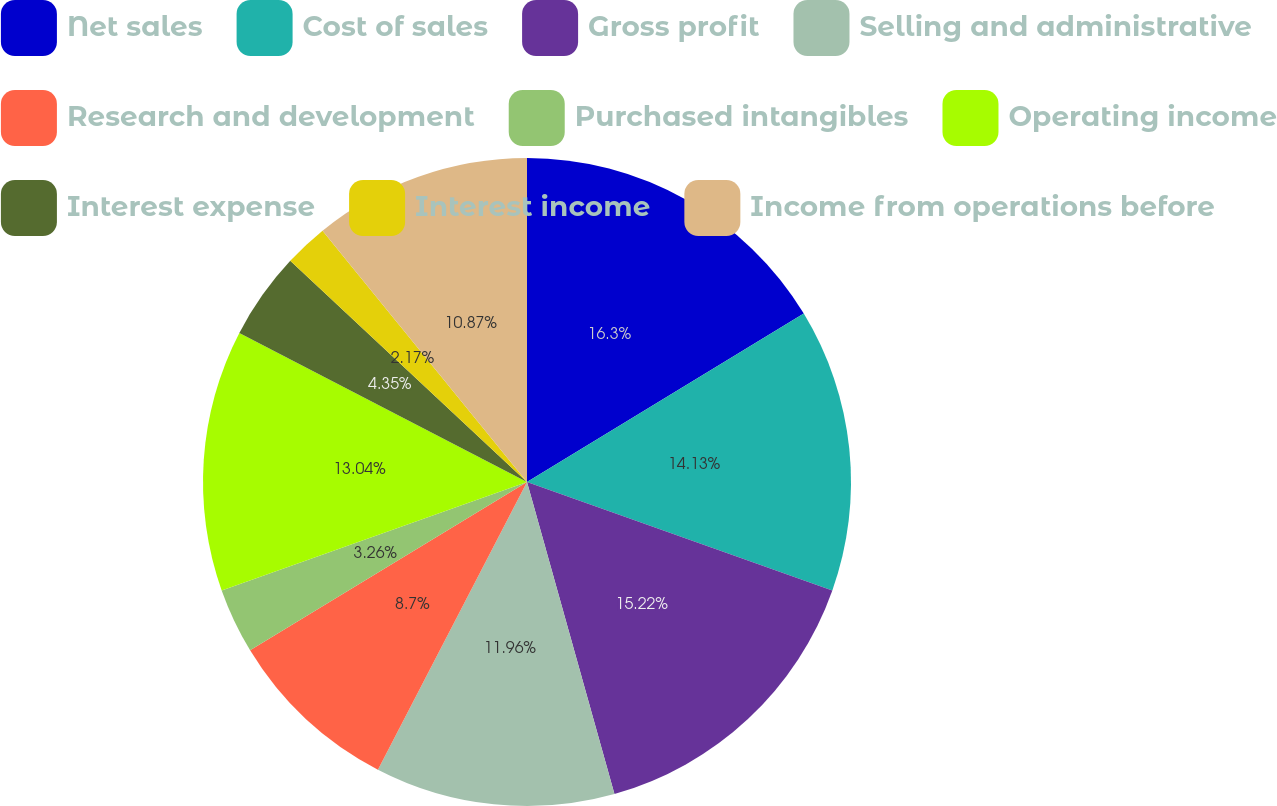<chart> <loc_0><loc_0><loc_500><loc_500><pie_chart><fcel>Net sales<fcel>Cost of sales<fcel>Gross profit<fcel>Selling and administrative<fcel>Research and development<fcel>Purchased intangibles<fcel>Operating income<fcel>Interest expense<fcel>Interest income<fcel>Income from operations before<nl><fcel>16.3%<fcel>14.13%<fcel>15.22%<fcel>11.96%<fcel>8.7%<fcel>3.26%<fcel>13.04%<fcel>4.35%<fcel>2.17%<fcel>10.87%<nl></chart> 